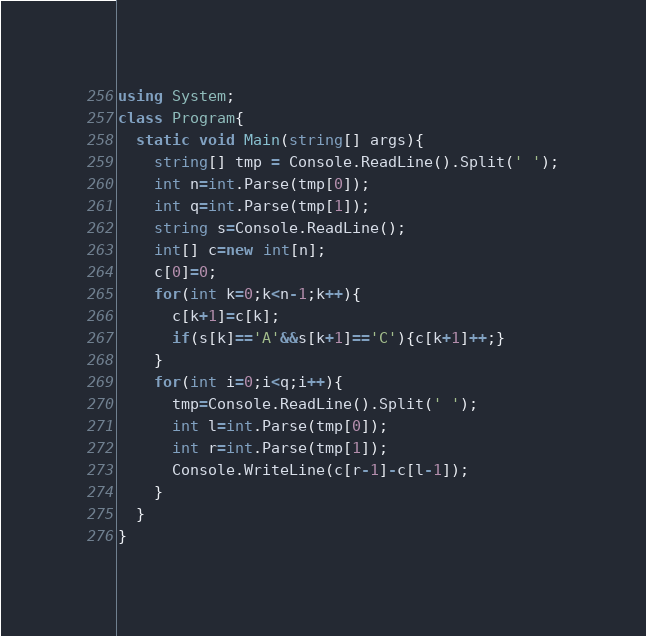Convert code to text. <code><loc_0><loc_0><loc_500><loc_500><_C#_>using System;
class Program{
  static void Main(string[] args){
    string[] tmp = Console.ReadLine().Split(' ');
    int n=int.Parse(tmp[0]);
    int q=int.Parse(tmp[1]);
    string s=Console.ReadLine();
    int[] c=new int[n];
    c[0]=0;
    for(int k=0;k<n-1;k++){
      c[k+1]=c[k];
      if(s[k]=='A'&&s[k+1]=='C'){c[k+1]++;}
    }
    for(int i=0;i<q;i++){
      tmp=Console.ReadLine().Split(' ');
      int l=int.Parse(tmp[0]);
      int r=int.Parse(tmp[1]);
      Console.WriteLine(c[r-1]-c[l-1]);
    }
  }
}
</code> 